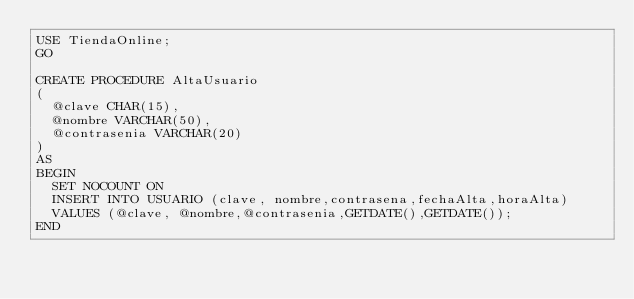<code> <loc_0><loc_0><loc_500><loc_500><_SQL_>USE TiendaOnline;
GO

CREATE PROCEDURE AltaUsuario
(
	@clave CHAR(15),
	@nombre VARCHAR(50),
	@contrasenia VARCHAR(20)
)
AS
BEGIN
	SET NOCOUNT ON
	INSERT INTO USUARIO (clave, nombre,contrasena,fechaAlta,horaAlta)
	VALUES (@clave, @nombre,@contrasenia,GETDATE(),GETDATE());
END</code> 